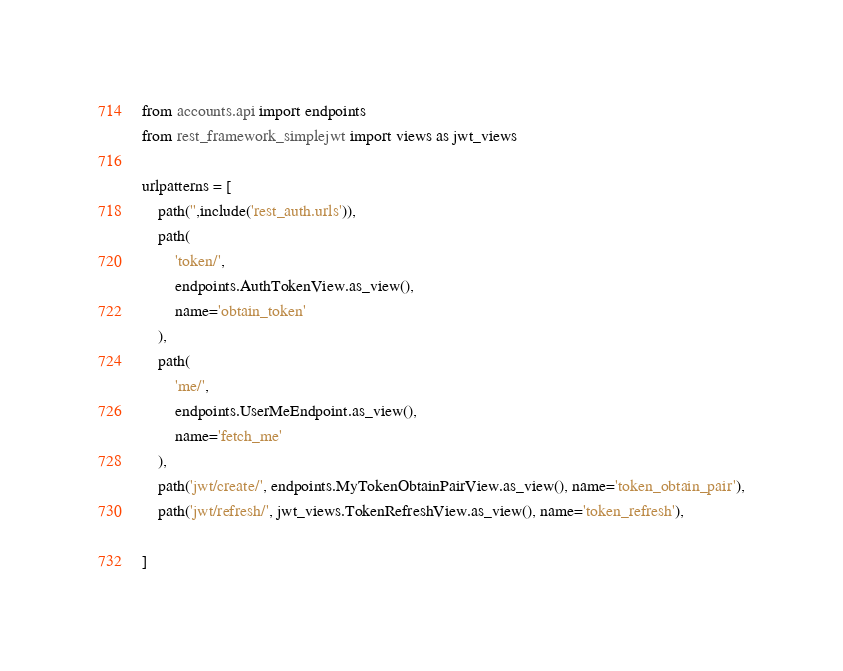Convert code to text. <code><loc_0><loc_0><loc_500><loc_500><_Python_>from accounts.api import endpoints
from rest_framework_simplejwt import views as jwt_views

urlpatterns = [
    path('',include('rest_auth.urls')),
    path(
        'token/',
        endpoints.AuthTokenView.as_view(),
        name='obtain_token'
    ),
    path(
        'me/',
        endpoints.UserMeEndpoint.as_view(),
        name='fetch_me'
    ),
    path('jwt/create/', endpoints.MyTokenObtainPairView.as_view(), name='token_obtain_pair'),
    path('jwt/refresh/', jwt_views.TokenRefreshView.as_view(), name='token_refresh'),

]</code> 